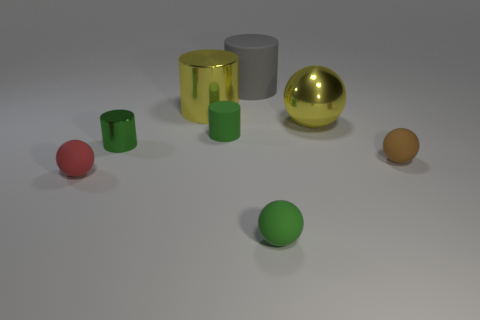There is a big yellow object that is the same shape as the brown rubber object; what is its material?
Give a very brief answer. Metal. What number of yellow shiny balls are the same size as the green sphere?
Provide a succinct answer. 0. What is the shape of the large gray object?
Give a very brief answer. Cylinder. What is the size of the cylinder that is in front of the gray rubber cylinder and to the right of the large yellow shiny cylinder?
Provide a short and direct response. Small. There is a large yellow thing that is to the left of the large gray cylinder; what material is it?
Offer a very short reply. Metal. Is the color of the large metallic sphere the same as the matte ball that is on the left side of the yellow shiny cylinder?
Your response must be concise. No. How many objects are small rubber objects that are left of the big sphere or green objects on the right side of the gray matte object?
Provide a succinct answer. 3. There is a big object that is to the right of the large yellow cylinder and behind the yellow shiny ball; what color is it?
Your response must be concise. Gray. Is the number of large matte objects greater than the number of tiny purple metal spheres?
Keep it short and to the point. Yes. Do the big metallic thing behind the large ball and the large gray rubber object have the same shape?
Offer a terse response. Yes. 